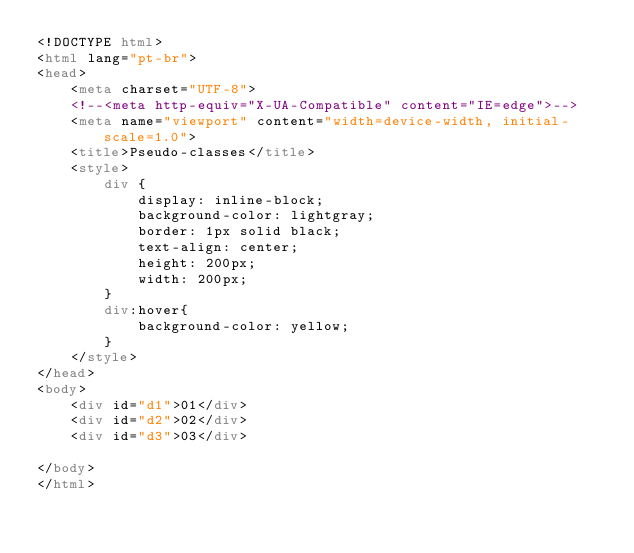<code> <loc_0><loc_0><loc_500><loc_500><_HTML_><!DOCTYPE html>
<html lang="pt-br">
<head>
    <meta charset="UTF-8">
    <!--<meta http-equiv="X-UA-Compatible" content="IE=edge">-->
    <meta name="viewport" content="width=device-width, initial-scale=1.0">
    <title>Pseudo-classes</title>
    <style>
        div {
            display: inline-block;
            background-color: lightgray;
            border: 1px solid black;
            text-align: center;
            height: 200px;
            width: 200px;
        }
        div:hover{
            background-color: yellow;
        }
    </style>
</head>
<body>
    <div id="d1">01</div>
    <div id="d2">02</div>
    <div id="d3">03</div>
    
</body>
</html></code> 